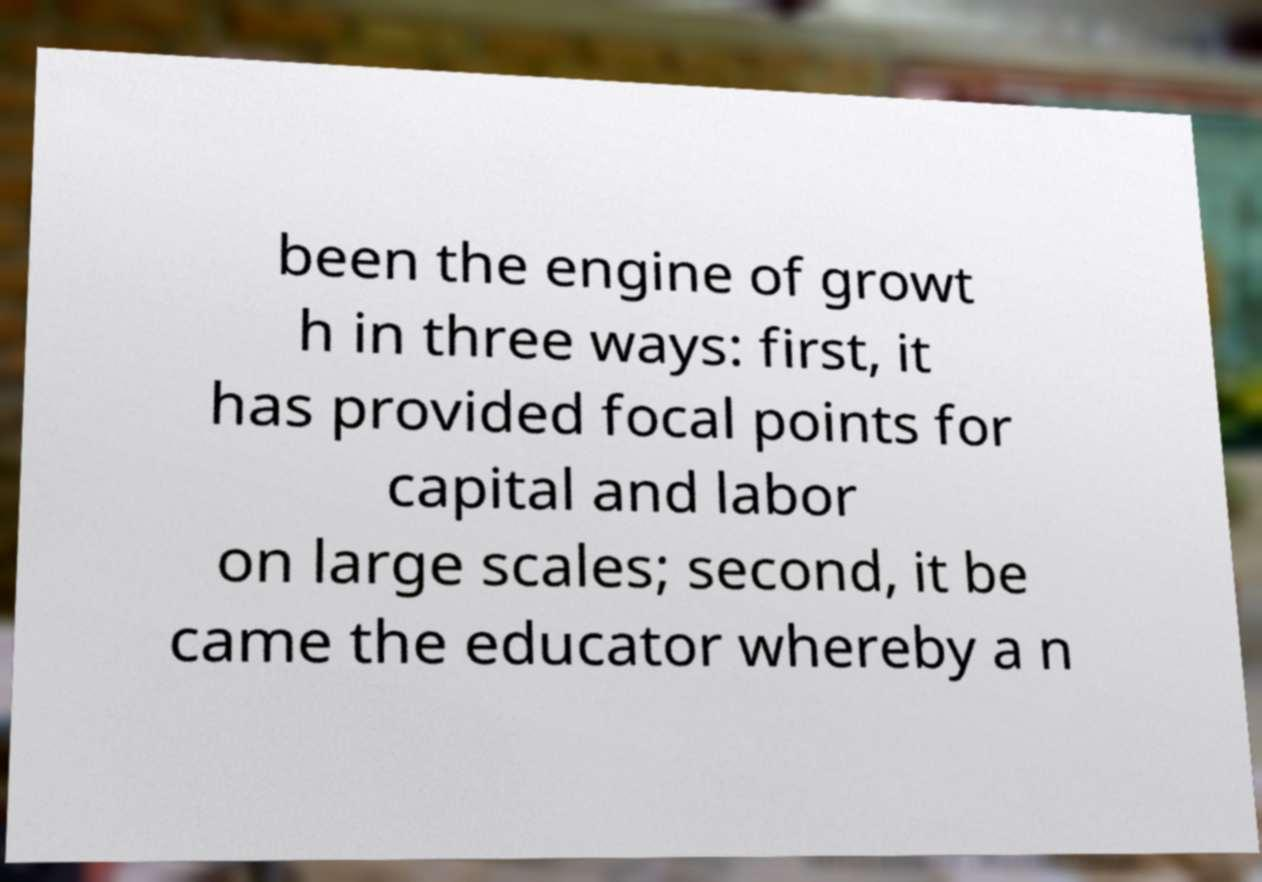I need the written content from this picture converted into text. Can you do that? been the engine of growt h in three ways: first, it has provided focal points for capital and labor on large scales; second, it be came the educator whereby a n 